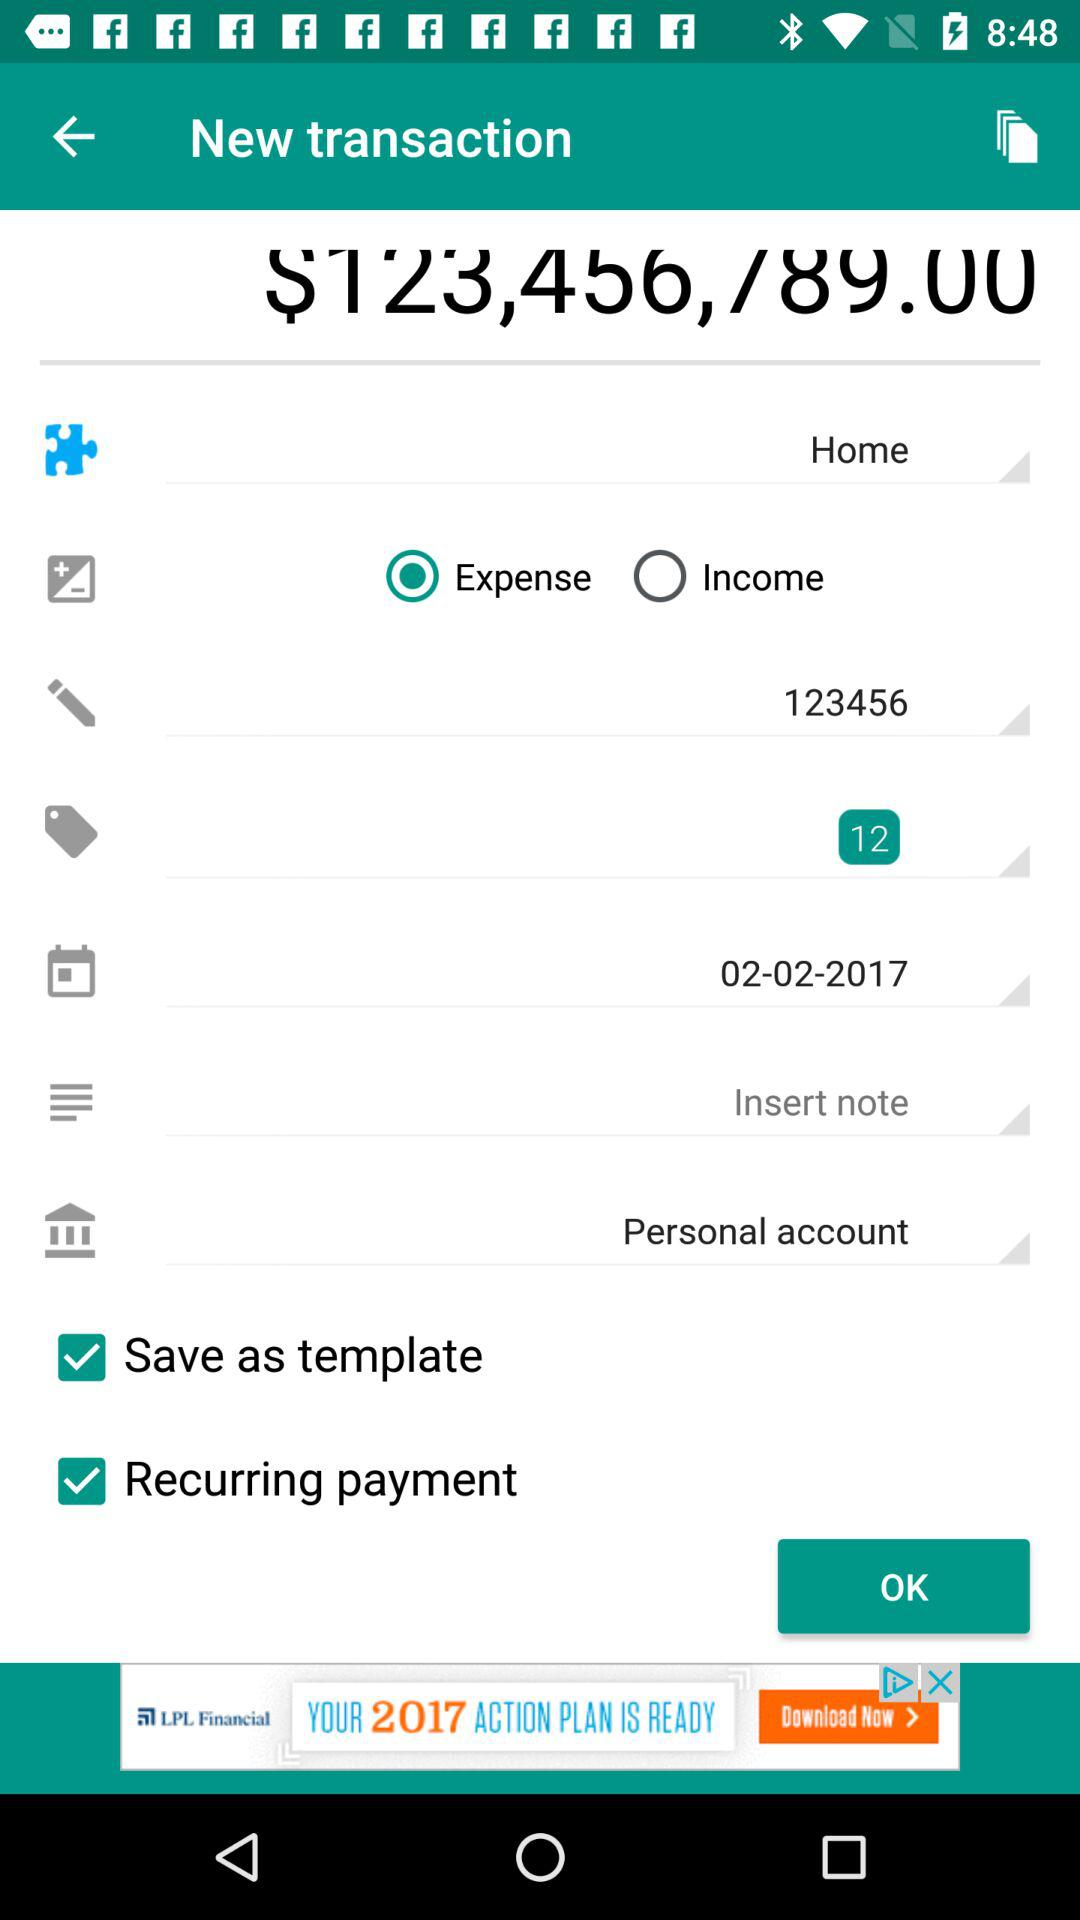Through which type of account is the transaction done? The transaction is done through the personal account. 